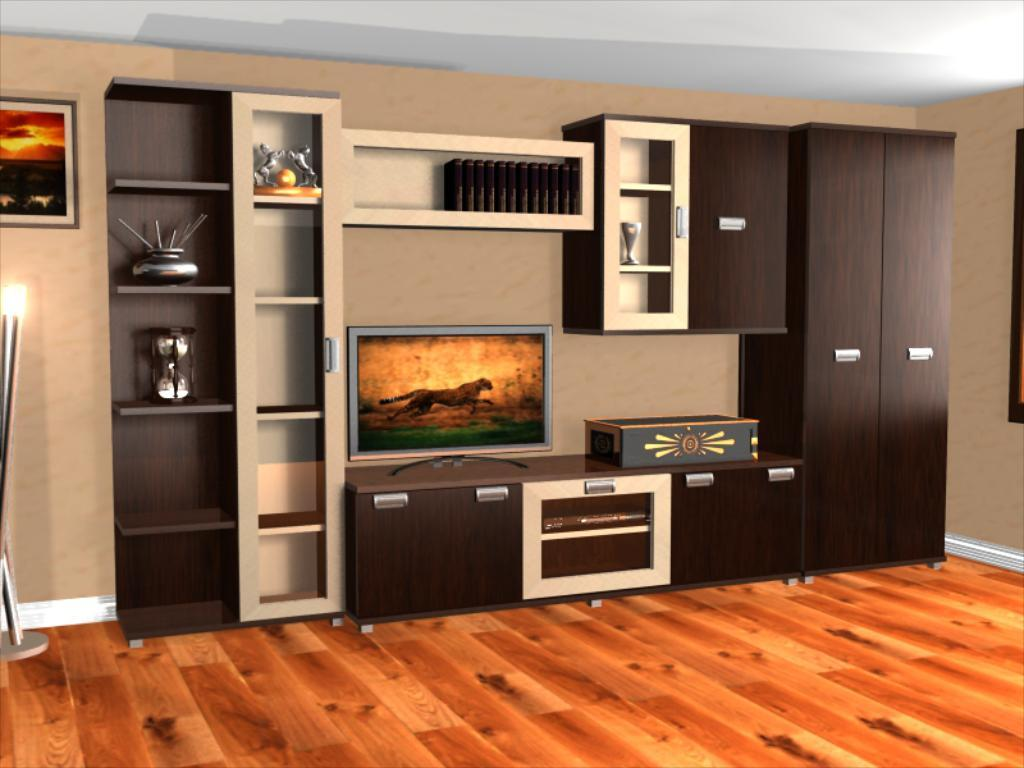What type of furniture is present in the image? There are cupboards in the image. What electronic device can be seen in the image? There is a television in the image. What can be found on the shelves in the image? There are items on the shelves in the image. What is hanging on the wall in the image? There is a photo frame on the wall in the image. Where is the light located in the image? There is a light on the left side of the image. What type of disease is depicted in the photo frame on the wall? There is no disease depicted in the photo frame on the wall; it is a photo frame containing a photograph or artwork. How many toes can be seen on the cupboards in the image? There are no toes present on the cupboards in the image; they are pieces of furniture. 